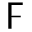Convert formula to latex. <formula><loc_0><loc_0><loc_500><loc_500>\digamma</formula> 